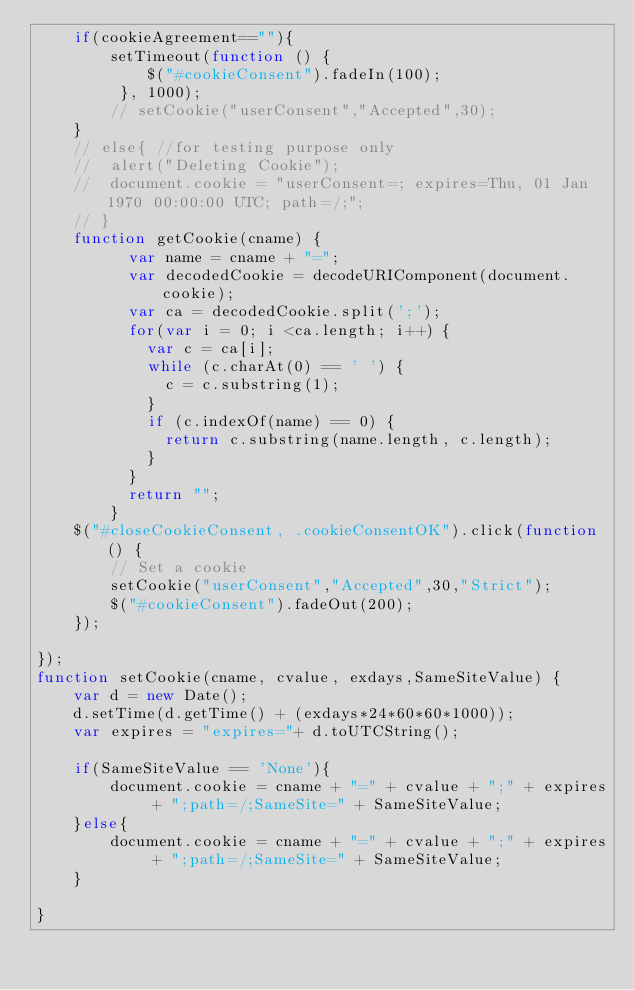<code> <loc_0><loc_0><loc_500><loc_500><_JavaScript_>	if(cookieAgreement==""){
		setTimeout(function () {
	        $("#cookieConsent").fadeIn(100);
	     }, 1000);
		// setCookie("userConsent","Accepted",30);
	}
	// else{ //for testing purpose only
	// 	alert("Deleting Cookie");
	// 	document.cookie = "userConsent=; expires=Thu, 01 Jan 1970 00:00:00 UTC; path=/;";
	// }
	function getCookie(cname) {
		  var name = cname + "=";
		  var decodedCookie = decodeURIComponent(document.cookie);
		  var ca = decodedCookie.split(';');
		  for(var i = 0; i <ca.length; i++) {
		    var c = ca[i];
		    while (c.charAt(0) == ' ') {
		      c = c.substring(1);
		    }
		    if (c.indexOf(name) == 0) {
		      return c.substring(name.length, c.length);
		    }
		  }
		  return "";
		}
    $("#closeCookieConsent, .cookieConsentOK").click(function() {
    	// Set a cookie
		setCookie("userConsent","Accepted",30,"Strict");
		$("#cookieConsent").fadeOut(200);
    });

}); 
function setCookie(cname, cvalue, exdays,SameSiteValue) {
	var d = new Date();
	d.setTime(d.getTime() + (exdays*24*60*60*1000));
	var expires = "expires="+ d.toUTCString();
	
	if(SameSiteValue == 'None'){
		document.cookie = cname + "=" + cvalue + ";" + expires + ";path=/;SameSite=" + SameSiteValue;
	}else{
		document.cookie = cname + "=" + cvalue + ";" + expires + ";path=/;SameSite=" + SameSiteValue;
	}

}</code> 